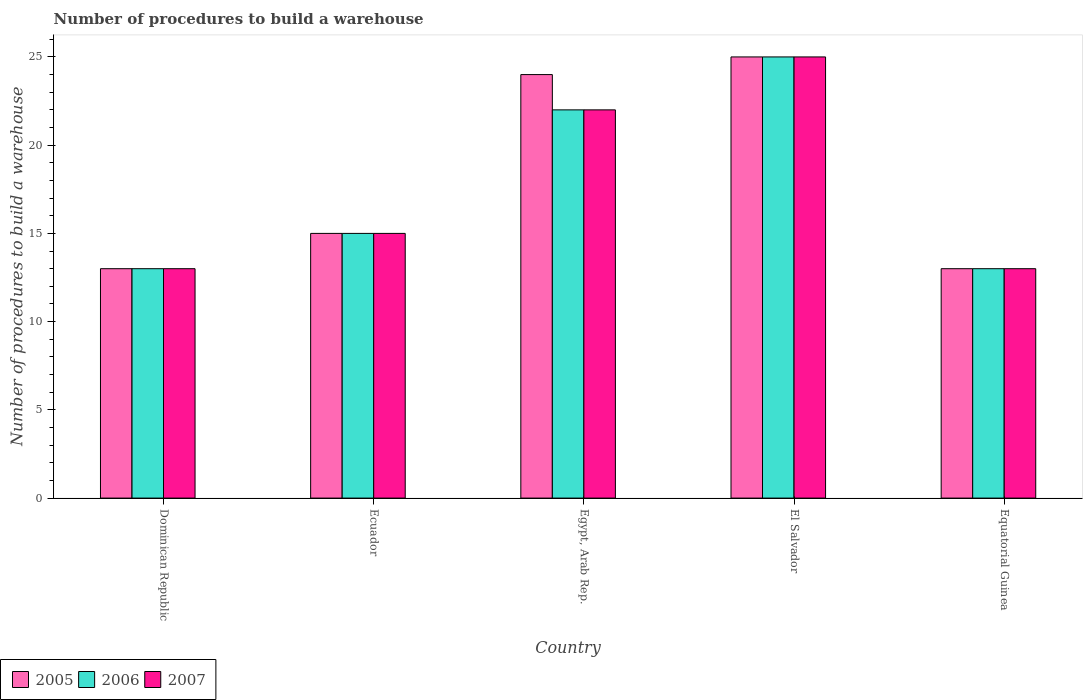How many groups of bars are there?
Give a very brief answer. 5. Are the number of bars per tick equal to the number of legend labels?
Keep it short and to the point. Yes. Are the number of bars on each tick of the X-axis equal?
Make the answer very short. Yes. How many bars are there on the 5th tick from the left?
Your answer should be compact. 3. How many bars are there on the 4th tick from the right?
Make the answer very short. 3. What is the label of the 1st group of bars from the left?
Keep it short and to the point. Dominican Republic. In how many cases, is the number of bars for a given country not equal to the number of legend labels?
Keep it short and to the point. 0. What is the number of procedures to build a warehouse in in 2006 in Ecuador?
Your answer should be compact. 15. In which country was the number of procedures to build a warehouse in in 2005 maximum?
Provide a short and direct response. El Salvador. In which country was the number of procedures to build a warehouse in in 2005 minimum?
Provide a short and direct response. Dominican Republic. What is the total number of procedures to build a warehouse in in 2007 in the graph?
Keep it short and to the point. 88. What is the difference between the number of procedures to build a warehouse in in 2006 in Equatorial Guinea and the number of procedures to build a warehouse in in 2007 in Egypt, Arab Rep.?
Provide a succinct answer. -9. What is the average number of procedures to build a warehouse in in 2005 per country?
Offer a very short reply. 18. What is the difference between the number of procedures to build a warehouse in of/in 2005 and number of procedures to build a warehouse in of/in 2007 in Equatorial Guinea?
Offer a terse response. 0. In how many countries, is the number of procedures to build a warehouse in in 2005 greater than 8?
Ensure brevity in your answer.  5. What is the ratio of the number of procedures to build a warehouse in in 2005 in Dominican Republic to that in Ecuador?
Offer a very short reply. 0.87. What is the difference between the highest and the second highest number of procedures to build a warehouse in in 2006?
Keep it short and to the point. 3. What does the 3rd bar from the right in Ecuador represents?
Give a very brief answer. 2005. Is it the case that in every country, the sum of the number of procedures to build a warehouse in in 2005 and number of procedures to build a warehouse in in 2007 is greater than the number of procedures to build a warehouse in in 2006?
Make the answer very short. Yes. How many bars are there?
Provide a succinct answer. 15. Are all the bars in the graph horizontal?
Your answer should be compact. No. What is the difference between two consecutive major ticks on the Y-axis?
Ensure brevity in your answer.  5. Does the graph contain any zero values?
Provide a succinct answer. No. Does the graph contain grids?
Your answer should be very brief. No. How many legend labels are there?
Your answer should be compact. 3. How are the legend labels stacked?
Give a very brief answer. Horizontal. What is the title of the graph?
Keep it short and to the point. Number of procedures to build a warehouse. Does "2007" appear as one of the legend labels in the graph?
Your answer should be very brief. Yes. What is the label or title of the Y-axis?
Give a very brief answer. Number of procedures to build a warehouse. What is the Number of procedures to build a warehouse in 2006 in Dominican Republic?
Give a very brief answer. 13. What is the Number of procedures to build a warehouse of 2005 in Ecuador?
Provide a succinct answer. 15. What is the Number of procedures to build a warehouse in 2007 in El Salvador?
Offer a terse response. 25. What is the Number of procedures to build a warehouse in 2005 in Equatorial Guinea?
Your answer should be very brief. 13. What is the Number of procedures to build a warehouse of 2006 in Equatorial Guinea?
Give a very brief answer. 13. Across all countries, what is the maximum Number of procedures to build a warehouse in 2007?
Provide a short and direct response. 25. Across all countries, what is the minimum Number of procedures to build a warehouse of 2005?
Ensure brevity in your answer.  13. Across all countries, what is the minimum Number of procedures to build a warehouse in 2007?
Your answer should be very brief. 13. What is the total Number of procedures to build a warehouse of 2005 in the graph?
Your response must be concise. 90. What is the total Number of procedures to build a warehouse of 2007 in the graph?
Your answer should be very brief. 88. What is the difference between the Number of procedures to build a warehouse in 2005 in Dominican Republic and that in Ecuador?
Ensure brevity in your answer.  -2. What is the difference between the Number of procedures to build a warehouse of 2007 in Dominican Republic and that in Egypt, Arab Rep.?
Your answer should be very brief. -9. What is the difference between the Number of procedures to build a warehouse of 2005 in Dominican Republic and that in El Salvador?
Make the answer very short. -12. What is the difference between the Number of procedures to build a warehouse in 2006 in Dominican Republic and that in El Salvador?
Give a very brief answer. -12. What is the difference between the Number of procedures to build a warehouse in 2005 in Dominican Republic and that in Equatorial Guinea?
Make the answer very short. 0. What is the difference between the Number of procedures to build a warehouse in 2006 in Dominican Republic and that in Equatorial Guinea?
Offer a very short reply. 0. What is the difference between the Number of procedures to build a warehouse in 2007 in Dominican Republic and that in Equatorial Guinea?
Ensure brevity in your answer.  0. What is the difference between the Number of procedures to build a warehouse in 2005 in Ecuador and that in Egypt, Arab Rep.?
Ensure brevity in your answer.  -9. What is the difference between the Number of procedures to build a warehouse of 2006 in Ecuador and that in Egypt, Arab Rep.?
Provide a short and direct response. -7. What is the difference between the Number of procedures to build a warehouse of 2005 in Ecuador and that in El Salvador?
Your answer should be compact. -10. What is the difference between the Number of procedures to build a warehouse in 2007 in Ecuador and that in El Salvador?
Provide a succinct answer. -10. What is the difference between the Number of procedures to build a warehouse of 2007 in Ecuador and that in Equatorial Guinea?
Offer a very short reply. 2. What is the difference between the Number of procedures to build a warehouse of 2007 in Egypt, Arab Rep. and that in El Salvador?
Provide a short and direct response. -3. What is the difference between the Number of procedures to build a warehouse in 2005 in Egypt, Arab Rep. and that in Equatorial Guinea?
Keep it short and to the point. 11. What is the difference between the Number of procedures to build a warehouse of 2006 in Egypt, Arab Rep. and that in Equatorial Guinea?
Provide a succinct answer. 9. What is the difference between the Number of procedures to build a warehouse in 2007 in Egypt, Arab Rep. and that in Equatorial Guinea?
Offer a very short reply. 9. What is the difference between the Number of procedures to build a warehouse of 2005 in El Salvador and that in Equatorial Guinea?
Provide a short and direct response. 12. What is the difference between the Number of procedures to build a warehouse of 2006 in El Salvador and that in Equatorial Guinea?
Keep it short and to the point. 12. What is the difference between the Number of procedures to build a warehouse in 2007 in El Salvador and that in Equatorial Guinea?
Ensure brevity in your answer.  12. What is the difference between the Number of procedures to build a warehouse of 2005 in Dominican Republic and the Number of procedures to build a warehouse of 2007 in Ecuador?
Keep it short and to the point. -2. What is the difference between the Number of procedures to build a warehouse of 2005 in Dominican Republic and the Number of procedures to build a warehouse of 2007 in Egypt, Arab Rep.?
Ensure brevity in your answer.  -9. What is the difference between the Number of procedures to build a warehouse of 2005 in Dominican Republic and the Number of procedures to build a warehouse of 2007 in El Salvador?
Offer a terse response. -12. What is the difference between the Number of procedures to build a warehouse of 2005 in Dominican Republic and the Number of procedures to build a warehouse of 2006 in Equatorial Guinea?
Provide a short and direct response. 0. What is the difference between the Number of procedures to build a warehouse in 2006 in Dominican Republic and the Number of procedures to build a warehouse in 2007 in Equatorial Guinea?
Your response must be concise. 0. What is the difference between the Number of procedures to build a warehouse in 2006 in Ecuador and the Number of procedures to build a warehouse in 2007 in Egypt, Arab Rep.?
Your answer should be compact. -7. What is the difference between the Number of procedures to build a warehouse of 2005 in Ecuador and the Number of procedures to build a warehouse of 2006 in El Salvador?
Give a very brief answer. -10. What is the difference between the Number of procedures to build a warehouse in 2005 in Ecuador and the Number of procedures to build a warehouse in 2007 in El Salvador?
Your answer should be compact. -10. What is the difference between the Number of procedures to build a warehouse of 2005 in Ecuador and the Number of procedures to build a warehouse of 2006 in Equatorial Guinea?
Offer a terse response. 2. What is the difference between the Number of procedures to build a warehouse in 2006 in Ecuador and the Number of procedures to build a warehouse in 2007 in Equatorial Guinea?
Your answer should be very brief. 2. What is the difference between the Number of procedures to build a warehouse in 2005 in Egypt, Arab Rep. and the Number of procedures to build a warehouse in 2007 in El Salvador?
Provide a short and direct response. -1. What is the difference between the Number of procedures to build a warehouse of 2005 in Egypt, Arab Rep. and the Number of procedures to build a warehouse of 2006 in Equatorial Guinea?
Your answer should be compact. 11. What is the difference between the Number of procedures to build a warehouse in 2005 in Egypt, Arab Rep. and the Number of procedures to build a warehouse in 2007 in Equatorial Guinea?
Your answer should be compact. 11. What is the difference between the Number of procedures to build a warehouse of 2006 in Egypt, Arab Rep. and the Number of procedures to build a warehouse of 2007 in Equatorial Guinea?
Your answer should be very brief. 9. What is the difference between the Number of procedures to build a warehouse of 2005 in El Salvador and the Number of procedures to build a warehouse of 2006 in Equatorial Guinea?
Offer a terse response. 12. What is the difference between the Number of procedures to build a warehouse of 2005 in El Salvador and the Number of procedures to build a warehouse of 2007 in Equatorial Guinea?
Your answer should be very brief. 12. What is the difference between the Number of procedures to build a warehouse in 2006 in El Salvador and the Number of procedures to build a warehouse in 2007 in Equatorial Guinea?
Your answer should be very brief. 12. What is the difference between the Number of procedures to build a warehouse of 2005 and Number of procedures to build a warehouse of 2007 in Dominican Republic?
Offer a very short reply. 0. What is the difference between the Number of procedures to build a warehouse in 2005 and Number of procedures to build a warehouse in 2006 in Ecuador?
Make the answer very short. 0. What is the difference between the Number of procedures to build a warehouse of 2005 and Number of procedures to build a warehouse of 2007 in Ecuador?
Your response must be concise. 0. What is the difference between the Number of procedures to build a warehouse of 2005 and Number of procedures to build a warehouse of 2006 in Egypt, Arab Rep.?
Offer a terse response. 2. What is the difference between the Number of procedures to build a warehouse of 2006 and Number of procedures to build a warehouse of 2007 in Egypt, Arab Rep.?
Ensure brevity in your answer.  0. What is the difference between the Number of procedures to build a warehouse of 2006 and Number of procedures to build a warehouse of 2007 in Equatorial Guinea?
Make the answer very short. 0. What is the ratio of the Number of procedures to build a warehouse of 2005 in Dominican Republic to that in Ecuador?
Offer a terse response. 0.87. What is the ratio of the Number of procedures to build a warehouse in 2006 in Dominican Republic to that in Ecuador?
Provide a short and direct response. 0.87. What is the ratio of the Number of procedures to build a warehouse of 2007 in Dominican Republic to that in Ecuador?
Make the answer very short. 0.87. What is the ratio of the Number of procedures to build a warehouse in 2005 in Dominican Republic to that in Egypt, Arab Rep.?
Provide a short and direct response. 0.54. What is the ratio of the Number of procedures to build a warehouse in 2006 in Dominican Republic to that in Egypt, Arab Rep.?
Your answer should be compact. 0.59. What is the ratio of the Number of procedures to build a warehouse of 2007 in Dominican Republic to that in Egypt, Arab Rep.?
Ensure brevity in your answer.  0.59. What is the ratio of the Number of procedures to build a warehouse of 2005 in Dominican Republic to that in El Salvador?
Make the answer very short. 0.52. What is the ratio of the Number of procedures to build a warehouse of 2006 in Dominican Republic to that in El Salvador?
Offer a very short reply. 0.52. What is the ratio of the Number of procedures to build a warehouse of 2007 in Dominican Republic to that in El Salvador?
Keep it short and to the point. 0.52. What is the ratio of the Number of procedures to build a warehouse of 2005 in Dominican Republic to that in Equatorial Guinea?
Make the answer very short. 1. What is the ratio of the Number of procedures to build a warehouse of 2007 in Dominican Republic to that in Equatorial Guinea?
Make the answer very short. 1. What is the ratio of the Number of procedures to build a warehouse in 2006 in Ecuador to that in Egypt, Arab Rep.?
Your answer should be compact. 0.68. What is the ratio of the Number of procedures to build a warehouse in 2007 in Ecuador to that in Egypt, Arab Rep.?
Offer a terse response. 0.68. What is the ratio of the Number of procedures to build a warehouse in 2005 in Ecuador to that in El Salvador?
Offer a very short reply. 0.6. What is the ratio of the Number of procedures to build a warehouse of 2005 in Ecuador to that in Equatorial Guinea?
Your answer should be compact. 1.15. What is the ratio of the Number of procedures to build a warehouse of 2006 in Ecuador to that in Equatorial Guinea?
Offer a terse response. 1.15. What is the ratio of the Number of procedures to build a warehouse of 2007 in Ecuador to that in Equatorial Guinea?
Make the answer very short. 1.15. What is the ratio of the Number of procedures to build a warehouse in 2005 in Egypt, Arab Rep. to that in Equatorial Guinea?
Make the answer very short. 1.85. What is the ratio of the Number of procedures to build a warehouse of 2006 in Egypt, Arab Rep. to that in Equatorial Guinea?
Offer a very short reply. 1.69. What is the ratio of the Number of procedures to build a warehouse of 2007 in Egypt, Arab Rep. to that in Equatorial Guinea?
Ensure brevity in your answer.  1.69. What is the ratio of the Number of procedures to build a warehouse of 2005 in El Salvador to that in Equatorial Guinea?
Ensure brevity in your answer.  1.92. What is the ratio of the Number of procedures to build a warehouse of 2006 in El Salvador to that in Equatorial Guinea?
Offer a very short reply. 1.92. What is the ratio of the Number of procedures to build a warehouse of 2007 in El Salvador to that in Equatorial Guinea?
Give a very brief answer. 1.92. What is the difference between the highest and the second highest Number of procedures to build a warehouse in 2005?
Make the answer very short. 1. What is the difference between the highest and the second highest Number of procedures to build a warehouse of 2007?
Provide a short and direct response. 3. 